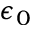<formula> <loc_0><loc_0><loc_500><loc_500>\epsilon _ { 0 }</formula> 